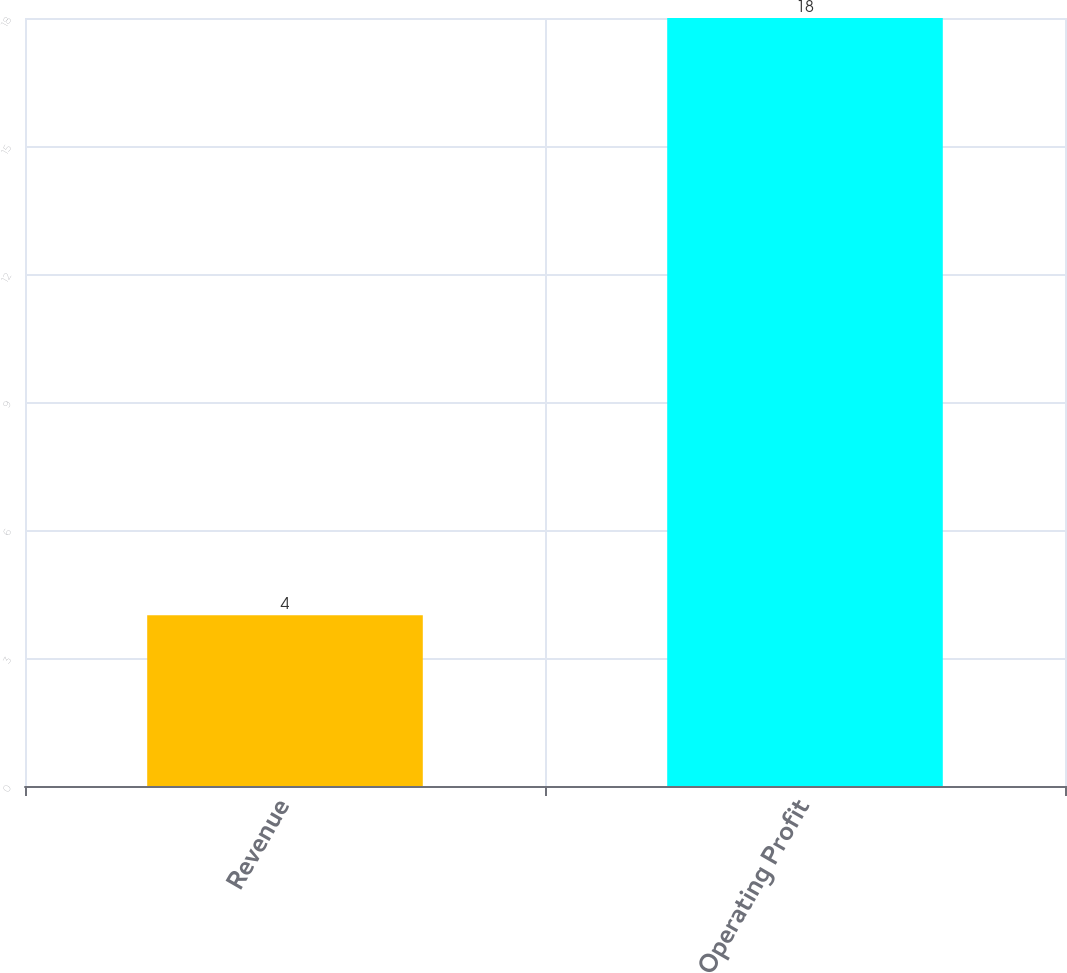Convert chart. <chart><loc_0><loc_0><loc_500><loc_500><bar_chart><fcel>Revenue<fcel>Operating Profit<nl><fcel>4<fcel>18<nl></chart> 